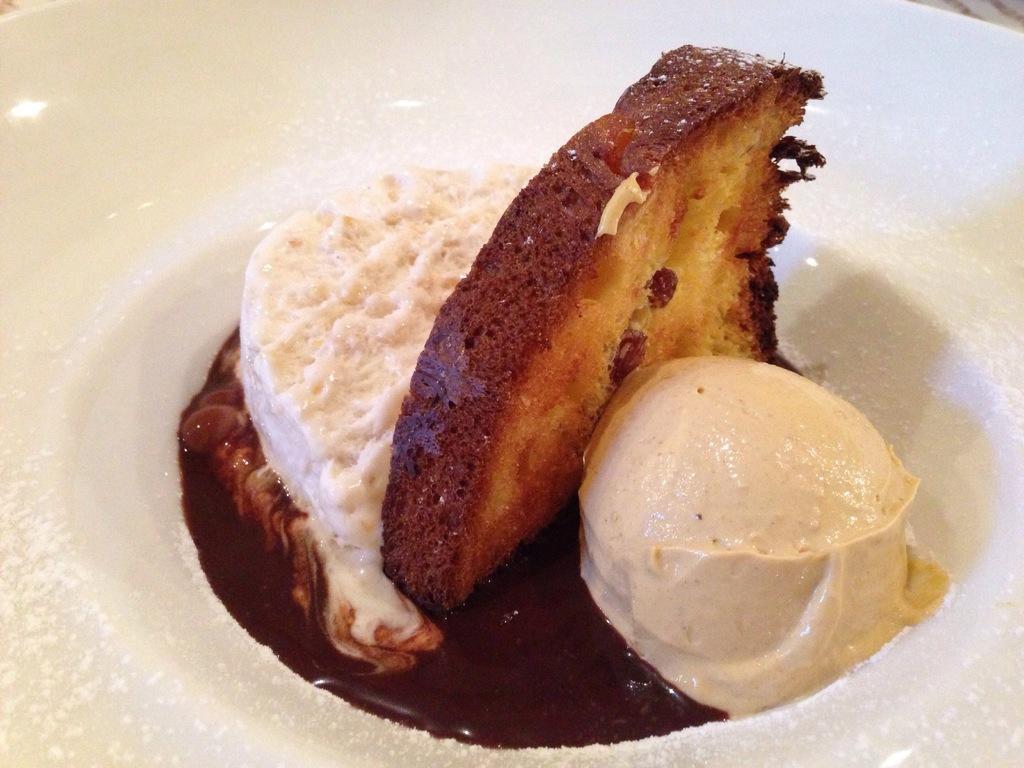Could you give a brief overview of what you see in this image? In this image we can see cream, bread, ice cream, chocolate in white plate. 